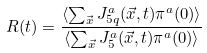<formula> <loc_0><loc_0><loc_500><loc_500>R ( t ) = \frac { \langle \sum _ { \vec { x } } J ^ { a } _ { 5 q } ( \vec { x } , t ) \pi ^ { a } ( 0 ) \rangle } { \langle \sum _ { \vec { x } } J ^ { a } _ { 5 } ( \vec { x } , t ) \pi ^ { a } ( 0 ) \rangle }</formula> 